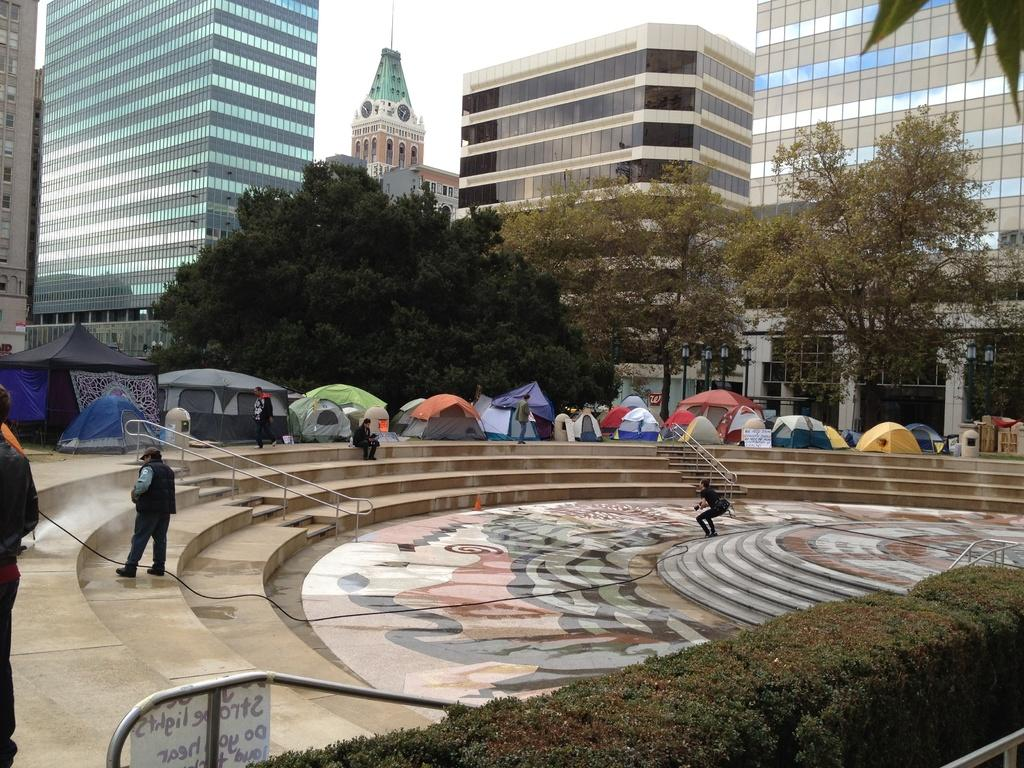How many people are present in the image? There are people in the image, but the exact number is not specified. What type of vegetation can be seen in the image? There are plants and trees in the image. What is the board on rods used for in the image? The purpose of the board on rods is not clear from the image. What architectural feature is present in the image? There are steps in the image. What is the wire used for in the image? The purpose of the wire is not clear from the image. What type of temporary shelter is present in the image? There are tents in the image. What type of natural environment is visible in the image? Trees and sky are visible in the image. What type of structures can be seen in the background of the image? There are buildings in the background of the image. What scent can be detected from the plants in the image? There is no information about the scent of the plants in the image. How does the digestion of the people in the image affect the surrounding environment? There is no information about the digestion of the people in the image, and therefore no impact on the environment can be determined. 